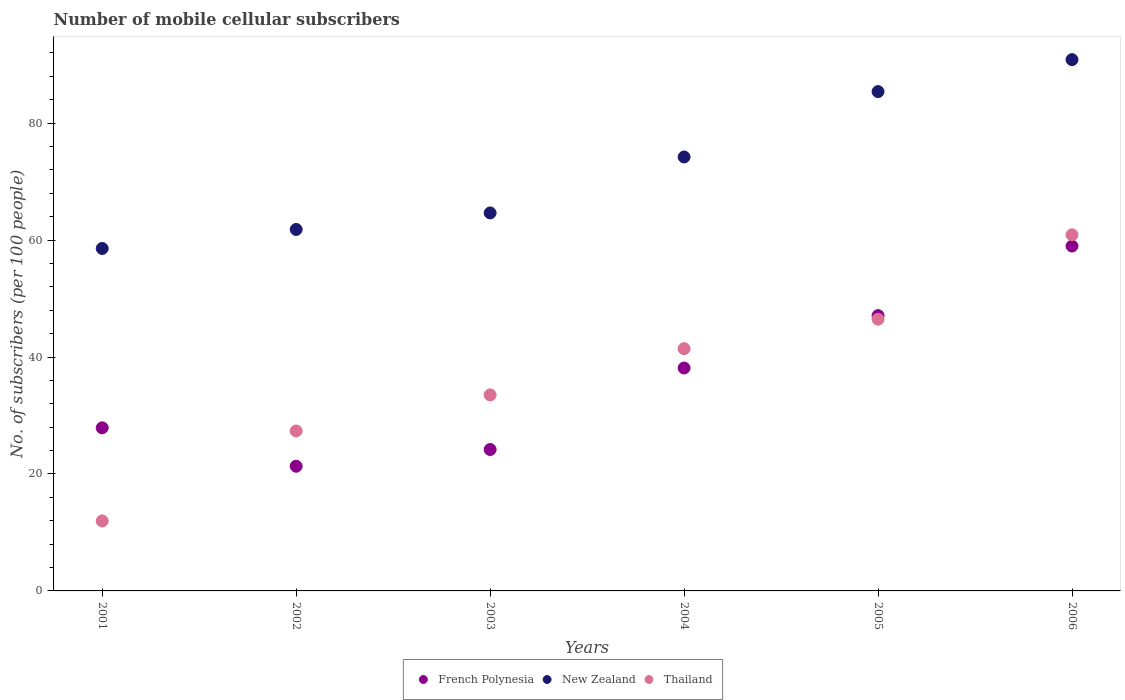What is the number of mobile cellular subscribers in New Zealand in 2003?
Ensure brevity in your answer.  64.64. Across all years, what is the maximum number of mobile cellular subscribers in New Zealand?
Provide a short and direct response. 90.85. Across all years, what is the minimum number of mobile cellular subscribers in French Polynesia?
Ensure brevity in your answer.  21.32. What is the total number of mobile cellular subscribers in New Zealand in the graph?
Ensure brevity in your answer.  435.47. What is the difference between the number of mobile cellular subscribers in Thailand in 2004 and that in 2005?
Provide a succinct answer. -5.03. What is the difference between the number of mobile cellular subscribers in New Zealand in 2003 and the number of mobile cellular subscribers in Thailand in 2005?
Keep it short and to the point. 18.18. What is the average number of mobile cellular subscribers in French Polynesia per year?
Your response must be concise. 36.26. In the year 2005, what is the difference between the number of mobile cellular subscribers in French Polynesia and number of mobile cellular subscribers in New Zealand?
Keep it short and to the point. -38.31. What is the ratio of the number of mobile cellular subscribers in New Zealand in 2002 to that in 2004?
Your response must be concise. 0.83. Is the number of mobile cellular subscribers in Thailand in 2001 less than that in 2002?
Ensure brevity in your answer.  Yes. Is the difference between the number of mobile cellular subscribers in French Polynesia in 2001 and 2004 greater than the difference between the number of mobile cellular subscribers in New Zealand in 2001 and 2004?
Your answer should be very brief. Yes. What is the difference between the highest and the second highest number of mobile cellular subscribers in New Zealand?
Make the answer very short. 5.47. What is the difference between the highest and the lowest number of mobile cellular subscribers in New Zealand?
Your answer should be very brief. 32.29. Is the sum of the number of mobile cellular subscribers in Thailand in 2002 and 2005 greater than the maximum number of mobile cellular subscribers in French Polynesia across all years?
Give a very brief answer. Yes. Is it the case that in every year, the sum of the number of mobile cellular subscribers in French Polynesia and number of mobile cellular subscribers in New Zealand  is greater than the number of mobile cellular subscribers in Thailand?
Offer a terse response. Yes. Is the number of mobile cellular subscribers in New Zealand strictly greater than the number of mobile cellular subscribers in Thailand over the years?
Your answer should be compact. Yes. Does the graph contain grids?
Keep it short and to the point. No. Where does the legend appear in the graph?
Make the answer very short. Bottom center. What is the title of the graph?
Your answer should be compact. Number of mobile cellular subscribers. Does "World" appear as one of the legend labels in the graph?
Your answer should be compact. No. What is the label or title of the Y-axis?
Make the answer very short. No. of subscribers (per 100 people). What is the No. of subscribers (per 100 people) of French Polynesia in 2001?
Offer a terse response. 27.89. What is the No. of subscribers (per 100 people) of New Zealand in 2001?
Provide a succinct answer. 58.56. What is the No. of subscribers (per 100 people) of Thailand in 2001?
Keep it short and to the point. 11.97. What is the No. of subscribers (per 100 people) in French Polynesia in 2002?
Offer a terse response. 21.32. What is the No. of subscribers (per 100 people) of New Zealand in 2002?
Your answer should be very brief. 61.81. What is the No. of subscribers (per 100 people) of Thailand in 2002?
Keep it short and to the point. 27.35. What is the No. of subscribers (per 100 people) of French Polynesia in 2003?
Keep it short and to the point. 24.18. What is the No. of subscribers (per 100 people) in New Zealand in 2003?
Give a very brief answer. 64.64. What is the No. of subscribers (per 100 people) in Thailand in 2003?
Offer a very short reply. 33.52. What is the No. of subscribers (per 100 people) of French Polynesia in 2004?
Give a very brief answer. 38.12. What is the No. of subscribers (per 100 people) of New Zealand in 2004?
Ensure brevity in your answer.  74.21. What is the No. of subscribers (per 100 people) of Thailand in 2004?
Offer a terse response. 41.43. What is the No. of subscribers (per 100 people) in French Polynesia in 2005?
Your answer should be compact. 47.08. What is the No. of subscribers (per 100 people) in New Zealand in 2005?
Your answer should be compact. 85.39. What is the No. of subscribers (per 100 people) of Thailand in 2005?
Give a very brief answer. 46.46. What is the No. of subscribers (per 100 people) in French Polynesia in 2006?
Your response must be concise. 58.98. What is the No. of subscribers (per 100 people) in New Zealand in 2006?
Provide a succinct answer. 90.85. What is the No. of subscribers (per 100 people) of Thailand in 2006?
Ensure brevity in your answer.  60.9. Across all years, what is the maximum No. of subscribers (per 100 people) in French Polynesia?
Offer a very short reply. 58.98. Across all years, what is the maximum No. of subscribers (per 100 people) of New Zealand?
Your response must be concise. 90.85. Across all years, what is the maximum No. of subscribers (per 100 people) in Thailand?
Your answer should be very brief. 60.9. Across all years, what is the minimum No. of subscribers (per 100 people) of French Polynesia?
Provide a short and direct response. 21.32. Across all years, what is the minimum No. of subscribers (per 100 people) in New Zealand?
Ensure brevity in your answer.  58.56. Across all years, what is the minimum No. of subscribers (per 100 people) of Thailand?
Your answer should be very brief. 11.97. What is the total No. of subscribers (per 100 people) in French Polynesia in the graph?
Give a very brief answer. 217.58. What is the total No. of subscribers (per 100 people) in New Zealand in the graph?
Keep it short and to the point. 435.47. What is the total No. of subscribers (per 100 people) in Thailand in the graph?
Your response must be concise. 221.64. What is the difference between the No. of subscribers (per 100 people) of French Polynesia in 2001 and that in 2002?
Make the answer very short. 6.57. What is the difference between the No. of subscribers (per 100 people) in New Zealand in 2001 and that in 2002?
Provide a succinct answer. -3.25. What is the difference between the No. of subscribers (per 100 people) of Thailand in 2001 and that in 2002?
Keep it short and to the point. -15.38. What is the difference between the No. of subscribers (per 100 people) in French Polynesia in 2001 and that in 2003?
Your answer should be compact. 3.71. What is the difference between the No. of subscribers (per 100 people) of New Zealand in 2001 and that in 2003?
Give a very brief answer. -6.08. What is the difference between the No. of subscribers (per 100 people) in Thailand in 2001 and that in 2003?
Your answer should be compact. -21.55. What is the difference between the No. of subscribers (per 100 people) in French Polynesia in 2001 and that in 2004?
Keep it short and to the point. -10.23. What is the difference between the No. of subscribers (per 100 people) of New Zealand in 2001 and that in 2004?
Provide a succinct answer. -15.64. What is the difference between the No. of subscribers (per 100 people) of Thailand in 2001 and that in 2004?
Offer a very short reply. -29.46. What is the difference between the No. of subscribers (per 100 people) of French Polynesia in 2001 and that in 2005?
Offer a terse response. -19.19. What is the difference between the No. of subscribers (per 100 people) of New Zealand in 2001 and that in 2005?
Your answer should be compact. -26.82. What is the difference between the No. of subscribers (per 100 people) in Thailand in 2001 and that in 2005?
Keep it short and to the point. -34.49. What is the difference between the No. of subscribers (per 100 people) in French Polynesia in 2001 and that in 2006?
Your response must be concise. -31.08. What is the difference between the No. of subscribers (per 100 people) in New Zealand in 2001 and that in 2006?
Provide a short and direct response. -32.29. What is the difference between the No. of subscribers (per 100 people) of Thailand in 2001 and that in 2006?
Ensure brevity in your answer.  -48.93. What is the difference between the No. of subscribers (per 100 people) of French Polynesia in 2002 and that in 2003?
Give a very brief answer. -2.86. What is the difference between the No. of subscribers (per 100 people) in New Zealand in 2002 and that in 2003?
Provide a succinct answer. -2.83. What is the difference between the No. of subscribers (per 100 people) in Thailand in 2002 and that in 2003?
Ensure brevity in your answer.  -6.17. What is the difference between the No. of subscribers (per 100 people) of French Polynesia in 2002 and that in 2004?
Your answer should be very brief. -16.8. What is the difference between the No. of subscribers (per 100 people) of New Zealand in 2002 and that in 2004?
Make the answer very short. -12.39. What is the difference between the No. of subscribers (per 100 people) of Thailand in 2002 and that in 2004?
Offer a very short reply. -14.08. What is the difference between the No. of subscribers (per 100 people) of French Polynesia in 2002 and that in 2005?
Make the answer very short. -25.76. What is the difference between the No. of subscribers (per 100 people) of New Zealand in 2002 and that in 2005?
Give a very brief answer. -23.57. What is the difference between the No. of subscribers (per 100 people) of Thailand in 2002 and that in 2005?
Ensure brevity in your answer.  -19.11. What is the difference between the No. of subscribers (per 100 people) of French Polynesia in 2002 and that in 2006?
Your answer should be compact. -37.65. What is the difference between the No. of subscribers (per 100 people) of New Zealand in 2002 and that in 2006?
Make the answer very short. -29.04. What is the difference between the No. of subscribers (per 100 people) in Thailand in 2002 and that in 2006?
Keep it short and to the point. -33.55. What is the difference between the No. of subscribers (per 100 people) of French Polynesia in 2003 and that in 2004?
Your answer should be compact. -13.94. What is the difference between the No. of subscribers (per 100 people) in New Zealand in 2003 and that in 2004?
Your answer should be compact. -9.57. What is the difference between the No. of subscribers (per 100 people) in Thailand in 2003 and that in 2004?
Keep it short and to the point. -7.91. What is the difference between the No. of subscribers (per 100 people) of French Polynesia in 2003 and that in 2005?
Make the answer very short. -22.9. What is the difference between the No. of subscribers (per 100 people) of New Zealand in 2003 and that in 2005?
Offer a very short reply. -20.75. What is the difference between the No. of subscribers (per 100 people) in Thailand in 2003 and that in 2005?
Give a very brief answer. -12.94. What is the difference between the No. of subscribers (per 100 people) in French Polynesia in 2003 and that in 2006?
Offer a very short reply. -34.79. What is the difference between the No. of subscribers (per 100 people) in New Zealand in 2003 and that in 2006?
Provide a short and direct response. -26.21. What is the difference between the No. of subscribers (per 100 people) of Thailand in 2003 and that in 2006?
Offer a very short reply. -27.38. What is the difference between the No. of subscribers (per 100 people) in French Polynesia in 2004 and that in 2005?
Your answer should be compact. -8.96. What is the difference between the No. of subscribers (per 100 people) of New Zealand in 2004 and that in 2005?
Give a very brief answer. -11.18. What is the difference between the No. of subscribers (per 100 people) in Thailand in 2004 and that in 2005?
Your answer should be compact. -5.03. What is the difference between the No. of subscribers (per 100 people) of French Polynesia in 2004 and that in 2006?
Make the answer very short. -20.85. What is the difference between the No. of subscribers (per 100 people) in New Zealand in 2004 and that in 2006?
Keep it short and to the point. -16.65. What is the difference between the No. of subscribers (per 100 people) of Thailand in 2004 and that in 2006?
Your response must be concise. -19.47. What is the difference between the No. of subscribers (per 100 people) of French Polynesia in 2005 and that in 2006?
Offer a very short reply. -11.9. What is the difference between the No. of subscribers (per 100 people) of New Zealand in 2005 and that in 2006?
Provide a short and direct response. -5.47. What is the difference between the No. of subscribers (per 100 people) of Thailand in 2005 and that in 2006?
Offer a terse response. -14.44. What is the difference between the No. of subscribers (per 100 people) of French Polynesia in 2001 and the No. of subscribers (per 100 people) of New Zealand in 2002?
Your answer should be compact. -33.92. What is the difference between the No. of subscribers (per 100 people) in French Polynesia in 2001 and the No. of subscribers (per 100 people) in Thailand in 2002?
Offer a terse response. 0.54. What is the difference between the No. of subscribers (per 100 people) of New Zealand in 2001 and the No. of subscribers (per 100 people) of Thailand in 2002?
Keep it short and to the point. 31.21. What is the difference between the No. of subscribers (per 100 people) of French Polynesia in 2001 and the No. of subscribers (per 100 people) of New Zealand in 2003?
Your answer should be compact. -36.75. What is the difference between the No. of subscribers (per 100 people) in French Polynesia in 2001 and the No. of subscribers (per 100 people) in Thailand in 2003?
Make the answer very short. -5.63. What is the difference between the No. of subscribers (per 100 people) in New Zealand in 2001 and the No. of subscribers (per 100 people) in Thailand in 2003?
Make the answer very short. 25.04. What is the difference between the No. of subscribers (per 100 people) of French Polynesia in 2001 and the No. of subscribers (per 100 people) of New Zealand in 2004?
Offer a very short reply. -46.31. What is the difference between the No. of subscribers (per 100 people) of French Polynesia in 2001 and the No. of subscribers (per 100 people) of Thailand in 2004?
Give a very brief answer. -13.54. What is the difference between the No. of subscribers (per 100 people) of New Zealand in 2001 and the No. of subscribers (per 100 people) of Thailand in 2004?
Make the answer very short. 17.13. What is the difference between the No. of subscribers (per 100 people) of French Polynesia in 2001 and the No. of subscribers (per 100 people) of New Zealand in 2005?
Provide a succinct answer. -57.49. What is the difference between the No. of subscribers (per 100 people) in French Polynesia in 2001 and the No. of subscribers (per 100 people) in Thailand in 2005?
Provide a short and direct response. -18.57. What is the difference between the No. of subscribers (per 100 people) of New Zealand in 2001 and the No. of subscribers (per 100 people) of Thailand in 2005?
Provide a succinct answer. 12.1. What is the difference between the No. of subscribers (per 100 people) of French Polynesia in 2001 and the No. of subscribers (per 100 people) of New Zealand in 2006?
Your response must be concise. -62.96. What is the difference between the No. of subscribers (per 100 people) in French Polynesia in 2001 and the No. of subscribers (per 100 people) in Thailand in 2006?
Make the answer very short. -33.01. What is the difference between the No. of subscribers (per 100 people) of New Zealand in 2001 and the No. of subscribers (per 100 people) of Thailand in 2006?
Provide a succinct answer. -2.34. What is the difference between the No. of subscribers (per 100 people) of French Polynesia in 2002 and the No. of subscribers (per 100 people) of New Zealand in 2003?
Your answer should be compact. -43.32. What is the difference between the No. of subscribers (per 100 people) in French Polynesia in 2002 and the No. of subscribers (per 100 people) in Thailand in 2003?
Ensure brevity in your answer.  -12.2. What is the difference between the No. of subscribers (per 100 people) in New Zealand in 2002 and the No. of subscribers (per 100 people) in Thailand in 2003?
Provide a short and direct response. 28.29. What is the difference between the No. of subscribers (per 100 people) in French Polynesia in 2002 and the No. of subscribers (per 100 people) in New Zealand in 2004?
Give a very brief answer. -52.88. What is the difference between the No. of subscribers (per 100 people) of French Polynesia in 2002 and the No. of subscribers (per 100 people) of Thailand in 2004?
Ensure brevity in your answer.  -20.11. What is the difference between the No. of subscribers (per 100 people) of New Zealand in 2002 and the No. of subscribers (per 100 people) of Thailand in 2004?
Make the answer very short. 20.38. What is the difference between the No. of subscribers (per 100 people) of French Polynesia in 2002 and the No. of subscribers (per 100 people) of New Zealand in 2005?
Offer a very short reply. -64.06. What is the difference between the No. of subscribers (per 100 people) in French Polynesia in 2002 and the No. of subscribers (per 100 people) in Thailand in 2005?
Give a very brief answer. -25.14. What is the difference between the No. of subscribers (per 100 people) of New Zealand in 2002 and the No. of subscribers (per 100 people) of Thailand in 2005?
Provide a succinct answer. 15.35. What is the difference between the No. of subscribers (per 100 people) in French Polynesia in 2002 and the No. of subscribers (per 100 people) in New Zealand in 2006?
Make the answer very short. -69.53. What is the difference between the No. of subscribers (per 100 people) in French Polynesia in 2002 and the No. of subscribers (per 100 people) in Thailand in 2006?
Keep it short and to the point. -39.58. What is the difference between the No. of subscribers (per 100 people) of New Zealand in 2002 and the No. of subscribers (per 100 people) of Thailand in 2006?
Your answer should be compact. 0.91. What is the difference between the No. of subscribers (per 100 people) in French Polynesia in 2003 and the No. of subscribers (per 100 people) in New Zealand in 2004?
Give a very brief answer. -50.03. What is the difference between the No. of subscribers (per 100 people) in French Polynesia in 2003 and the No. of subscribers (per 100 people) in Thailand in 2004?
Make the answer very short. -17.25. What is the difference between the No. of subscribers (per 100 people) in New Zealand in 2003 and the No. of subscribers (per 100 people) in Thailand in 2004?
Make the answer very short. 23.21. What is the difference between the No. of subscribers (per 100 people) of French Polynesia in 2003 and the No. of subscribers (per 100 people) of New Zealand in 2005?
Keep it short and to the point. -61.21. What is the difference between the No. of subscribers (per 100 people) of French Polynesia in 2003 and the No. of subscribers (per 100 people) of Thailand in 2005?
Offer a very short reply. -22.28. What is the difference between the No. of subscribers (per 100 people) of New Zealand in 2003 and the No. of subscribers (per 100 people) of Thailand in 2005?
Your answer should be compact. 18.18. What is the difference between the No. of subscribers (per 100 people) of French Polynesia in 2003 and the No. of subscribers (per 100 people) of New Zealand in 2006?
Offer a terse response. -66.67. What is the difference between the No. of subscribers (per 100 people) of French Polynesia in 2003 and the No. of subscribers (per 100 people) of Thailand in 2006?
Provide a short and direct response. -36.72. What is the difference between the No. of subscribers (per 100 people) in New Zealand in 2003 and the No. of subscribers (per 100 people) in Thailand in 2006?
Ensure brevity in your answer.  3.74. What is the difference between the No. of subscribers (per 100 people) of French Polynesia in 2004 and the No. of subscribers (per 100 people) of New Zealand in 2005?
Your response must be concise. -47.26. What is the difference between the No. of subscribers (per 100 people) of French Polynesia in 2004 and the No. of subscribers (per 100 people) of Thailand in 2005?
Offer a very short reply. -8.34. What is the difference between the No. of subscribers (per 100 people) in New Zealand in 2004 and the No. of subscribers (per 100 people) in Thailand in 2005?
Your answer should be very brief. 27.75. What is the difference between the No. of subscribers (per 100 people) of French Polynesia in 2004 and the No. of subscribers (per 100 people) of New Zealand in 2006?
Your response must be concise. -52.73. What is the difference between the No. of subscribers (per 100 people) of French Polynesia in 2004 and the No. of subscribers (per 100 people) of Thailand in 2006?
Offer a very short reply. -22.78. What is the difference between the No. of subscribers (per 100 people) of New Zealand in 2004 and the No. of subscribers (per 100 people) of Thailand in 2006?
Offer a terse response. 13.3. What is the difference between the No. of subscribers (per 100 people) of French Polynesia in 2005 and the No. of subscribers (per 100 people) of New Zealand in 2006?
Give a very brief answer. -43.77. What is the difference between the No. of subscribers (per 100 people) in French Polynesia in 2005 and the No. of subscribers (per 100 people) in Thailand in 2006?
Your answer should be compact. -13.82. What is the difference between the No. of subscribers (per 100 people) in New Zealand in 2005 and the No. of subscribers (per 100 people) in Thailand in 2006?
Provide a short and direct response. 24.48. What is the average No. of subscribers (per 100 people) of French Polynesia per year?
Give a very brief answer. 36.26. What is the average No. of subscribers (per 100 people) in New Zealand per year?
Give a very brief answer. 72.58. What is the average No. of subscribers (per 100 people) of Thailand per year?
Provide a short and direct response. 36.94. In the year 2001, what is the difference between the No. of subscribers (per 100 people) of French Polynesia and No. of subscribers (per 100 people) of New Zealand?
Offer a very short reply. -30.67. In the year 2001, what is the difference between the No. of subscribers (per 100 people) of French Polynesia and No. of subscribers (per 100 people) of Thailand?
Offer a very short reply. 15.92. In the year 2001, what is the difference between the No. of subscribers (per 100 people) of New Zealand and No. of subscribers (per 100 people) of Thailand?
Make the answer very short. 46.59. In the year 2002, what is the difference between the No. of subscribers (per 100 people) in French Polynesia and No. of subscribers (per 100 people) in New Zealand?
Make the answer very short. -40.49. In the year 2002, what is the difference between the No. of subscribers (per 100 people) of French Polynesia and No. of subscribers (per 100 people) of Thailand?
Offer a terse response. -6.03. In the year 2002, what is the difference between the No. of subscribers (per 100 people) of New Zealand and No. of subscribers (per 100 people) of Thailand?
Ensure brevity in your answer.  34.46. In the year 2003, what is the difference between the No. of subscribers (per 100 people) of French Polynesia and No. of subscribers (per 100 people) of New Zealand?
Provide a short and direct response. -40.46. In the year 2003, what is the difference between the No. of subscribers (per 100 people) of French Polynesia and No. of subscribers (per 100 people) of Thailand?
Give a very brief answer. -9.34. In the year 2003, what is the difference between the No. of subscribers (per 100 people) of New Zealand and No. of subscribers (per 100 people) of Thailand?
Offer a very short reply. 31.12. In the year 2004, what is the difference between the No. of subscribers (per 100 people) of French Polynesia and No. of subscribers (per 100 people) of New Zealand?
Offer a very short reply. -36.08. In the year 2004, what is the difference between the No. of subscribers (per 100 people) in French Polynesia and No. of subscribers (per 100 people) in Thailand?
Your response must be concise. -3.31. In the year 2004, what is the difference between the No. of subscribers (per 100 people) of New Zealand and No. of subscribers (per 100 people) of Thailand?
Your response must be concise. 32.78. In the year 2005, what is the difference between the No. of subscribers (per 100 people) of French Polynesia and No. of subscribers (per 100 people) of New Zealand?
Give a very brief answer. -38.31. In the year 2005, what is the difference between the No. of subscribers (per 100 people) of French Polynesia and No. of subscribers (per 100 people) of Thailand?
Ensure brevity in your answer.  0.62. In the year 2005, what is the difference between the No. of subscribers (per 100 people) of New Zealand and No. of subscribers (per 100 people) of Thailand?
Provide a succinct answer. 38.93. In the year 2006, what is the difference between the No. of subscribers (per 100 people) in French Polynesia and No. of subscribers (per 100 people) in New Zealand?
Your response must be concise. -31.88. In the year 2006, what is the difference between the No. of subscribers (per 100 people) of French Polynesia and No. of subscribers (per 100 people) of Thailand?
Offer a very short reply. -1.93. In the year 2006, what is the difference between the No. of subscribers (per 100 people) in New Zealand and No. of subscribers (per 100 people) in Thailand?
Make the answer very short. 29.95. What is the ratio of the No. of subscribers (per 100 people) in French Polynesia in 2001 to that in 2002?
Offer a very short reply. 1.31. What is the ratio of the No. of subscribers (per 100 people) in New Zealand in 2001 to that in 2002?
Offer a terse response. 0.95. What is the ratio of the No. of subscribers (per 100 people) of Thailand in 2001 to that in 2002?
Your answer should be compact. 0.44. What is the ratio of the No. of subscribers (per 100 people) in French Polynesia in 2001 to that in 2003?
Provide a succinct answer. 1.15. What is the ratio of the No. of subscribers (per 100 people) in New Zealand in 2001 to that in 2003?
Ensure brevity in your answer.  0.91. What is the ratio of the No. of subscribers (per 100 people) in Thailand in 2001 to that in 2003?
Your answer should be compact. 0.36. What is the ratio of the No. of subscribers (per 100 people) in French Polynesia in 2001 to that in 2004?
Give a very brief answer. 0.73. What is the ratio of the No. of subscribers (per 100 people) of New Zealand in 2001 to that in 2004?
Provide a short and direct response. 0.79. What is the ratio of the No. of subscribers (per 100 people) of Thailand in 2001 to that in 2004?
Your answer should be compact. 0.29. What is the ratio of the No. of subscribers (per 100 people) of French Polynesia in 2001 to that in 2005?
Provide a short and direct response. 0.59. What is the ratio of the No. of subscribers (per 100 people) in New Zealand in 2001 to that in 2005?
Your answer should be very brief. 0.69. What is the ratio of the No. of subscribers (per 100 people) in Thailand in 2001 to that in 2005?
Keep it short and to the point. 0.26. What is the ratio of the No. of subscribers (per 100 people) in French Polynesia in 2001 to that in 2006?
Keep it short and to the point. 0.47. What is the ratio of the No. of subscribers (per 100 people) in New Zealand in 2001 to that in 2006?
Provide a short and direct response. 0.64. What is the ratio of the No. of subscribers (per 100 people) of Thailand in 2001 to that in 2006?
Your answer should be very brief. 0.2. What is the ratio of the No. of subscribers (per 100 people) of French Polynesia in 2002 to that in 2003?
Provide a short and direct response. 0.88. What is the ratio of the No. of subscribers (per 100 people) in New Zealand in 2002 to that in 2003?
Your answer should be very brief. 0.96. What is the ratio of the No. of subscribers (per 100 people) of Thailand in 2002 to that in 2003?
Ensure brevity in your answer.  0.82. What is the ratio of the No. of subscribers (per 100 people) in French Polynesia in 2002 to that in 2004?
Your answer should be very brief. 0.56. What is the ratio of the No. of subscribers (per 100 people) in New Zealand in 2002 to that in 2004?
Keep it short and to the point. 0.83. What is the ratio of the No. of subscribers (per 100 people) of Thailand in 2002 to that in 2004?
Your answer should be very brief. 0.66. What is the ratio of the No. of subscribers (per 100 people) of French Polynesia in 2002 to that in 2005?
Your answer should be compact. 0.45. What is the ratio of the No. of subscribers (per 100 people) of New Zealand in 2002 to that in 2005?
Your answer should be very brief. 0.72. What is the ratio of the No. of subscribers (per 100 people) in Thailand in 2002 to that in 2005?
Provide a short and direct response. 0.59. What is the ratio of the No. of subscribers (per 100 people) of French Polynesia in 2002 to that in 2006?
Provide a short and direct response. 0.36. What is the ratio of the No. of subscribers (per 100 people) in New Zealand in 2002 to that in 2006?
Keep it short and to the point. 0.68. What is the ratio of the No. of subscribers (per 100 people) of Thailand in 2002 to that in 2006?
Your answer should be compact. 0.45. What is the ratio of the No. of subscribers (per 100 people) in French Polynesia in 2003 to that in 2004?
Offer a terse response. 0.63. What is the ratio of the No. of subscribers (per 100 people) of New Zealand in 2003 to that in 2004?
Your response must be concise. 0.87. What is the ratio of the No. of subscribers (per 100 people) of Thailand in 2003 to that in 2004?
Offer a very short reply. 0.81. What is the ratio of the No. of subscribers (per 100 people) in French Polynesia in 2003 to that in 2005?
Offer a terse response. 0.51. What is the ratio of the No. of subscribers (per 100 people) of New Zealand in 2003 to that in 2005?
Provide a short and direct response. 0.76. What is the ratio of the No. of subscribers (per 100 people) in Thailand in 2003 to that in 2005?
Offer a terse response. 0.72. What is the ratio of the No. of subscribers (per 100 people) of French Polynesia in 2003 to that in 2006?
Keep it short and to the point. 0.41. What is the ratio of the No. of subscribers (per 100 people) in New Zealand in 2003 to that in 2006?
Keep it short and to the point. 0.71. What is the ratio of the No. of subscribers (per 100 people) of Thailand in 2003 to that in 2006?
Provide a short and direct response. 0.55. What is the ratio of the No. of subscribers (per 100 people) in French Polynesia in 2004 to that in 2005?
Your answer should be very brief. 0.81. What is the ratio of the No. of subscribers (per 100 people) of New Zealand in 2004 to that in 2005?
Provide a succinct answer. 0.87. What is the ratio of the No. of subscribers (per 100 people) of Thailand in 2004 to that in 2005?
Ensure brevity in your answer.  0.89. What is the ratio of the No. of subscribers (per 100 people) of French Polynesia in 2004 to that in 2006?
Offer a very short reply. 0.65. What is the ratio of the No. of subscribers (per 100 people) in New Zealand in 2004 to that in 2006?
Your answer should be compact. 0.82. What is the ratio of the No. of subscribers (per 100 people) of Thailand in 2004 to that in 2006?
Give a very brief answer. 0.68. What is the ratio of the No. of subscribers (per 100 people) in French Polynesia in 2005 to that in 2006?
Ensure brevity in your answer.  0.8. What is the ratio of the No. of subscribers (per 100 people) in New Zealand in 2005 to that in 2006?
Keep it short and to the point. 0.94. What is the ratio of the No. of subscribers (per 100 people) in Thailand in 2005 to that in 2006?
Your answer should be very brief. 0.76. What is the difference between the highest and the second highest No. of subscribers (per 100 people) of French Polynesia?
Your response must be concise. 11.9. What is the difference between the highest and the second highest No. of subscribers (per 100 people) of New Zealand?
Provide a short and direct response. 5.47. What is the difference between the highest and the second highest No. of subscribers (per 100 people) of Thailand?
Provide a succinct answer. 14.44. What is the difference between the highest and the lowest No. of subscribers (per 100 people) of French Polynesia?
Your answer should be compact. 37.65. What is the difference between the highest and the lowest No. of subscribers (per 100 people) of New Zealand?
Your answer should be compact. 32.29. What is the difference between the highest and the lowest No. of subscribers (per 100 people) of Thailand?
Offer a terse response. 48.93. 